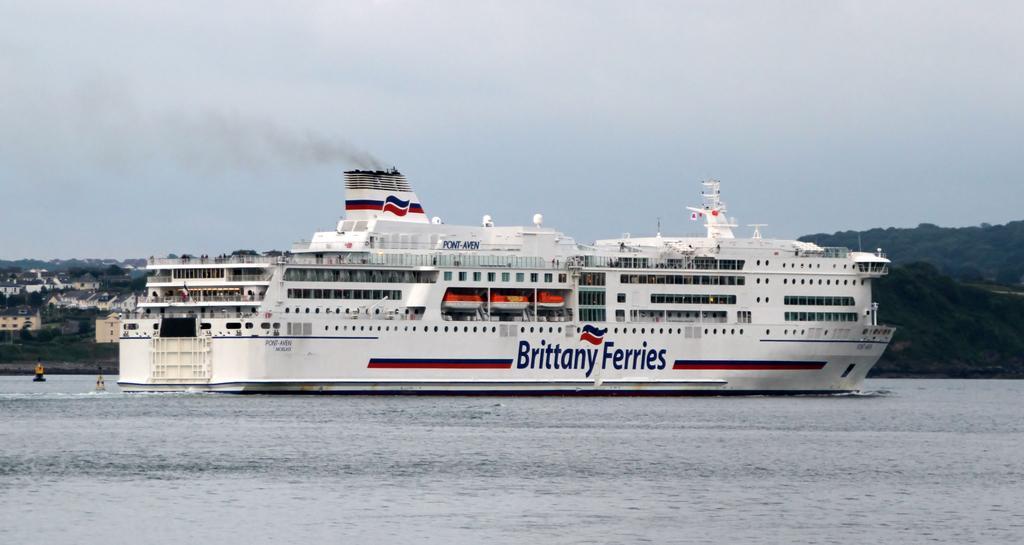Describe this image in one or two sentences. In this image there is water. There is a ship. There are boats. There are trees and mountains. There are buildings. There is a sky. 